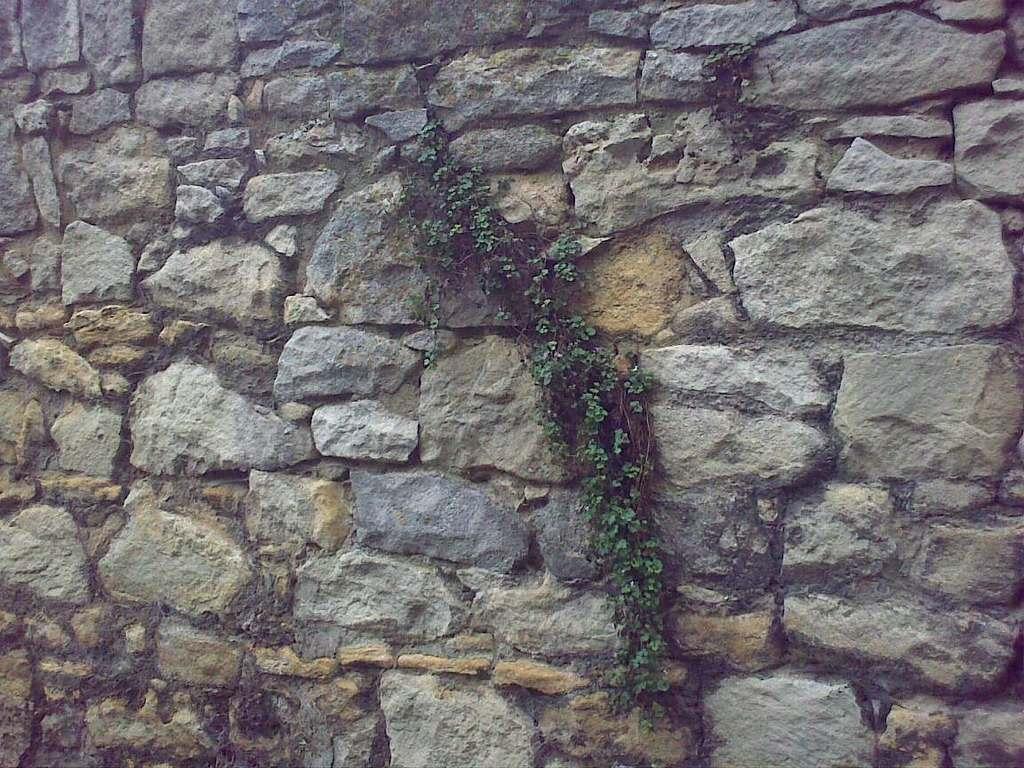Can you describe this image briefly? In this picture we can observe a stone wall. There are different sizes of stones. We can observe a plant on this stone wall. 